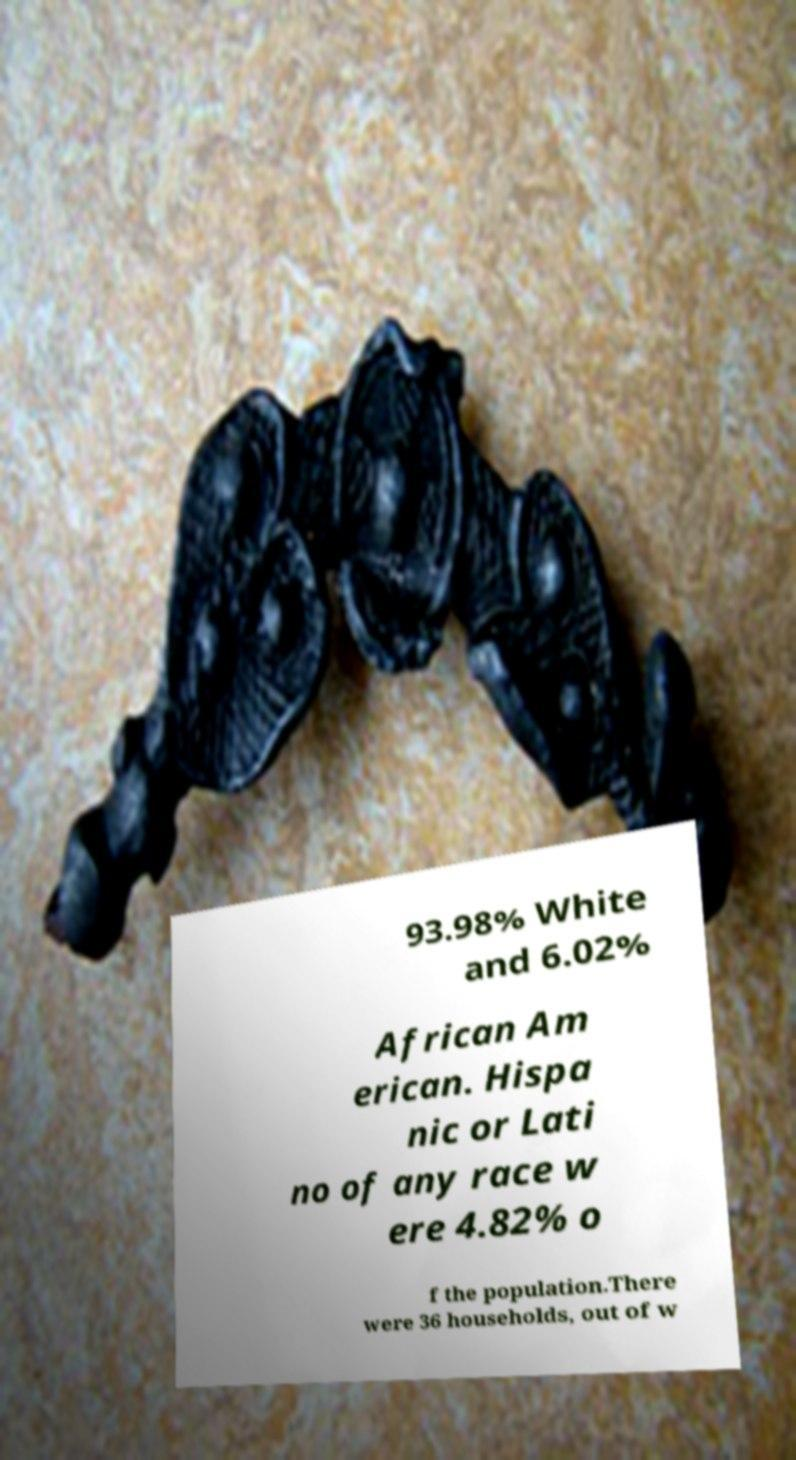Please read and relay the text visible in this image. What does it say? 93.98% White and 6.02% African Am erican. Hispa nic or Lati no of any race w ere 4.82% o f the population.There were 36 households, out of w 